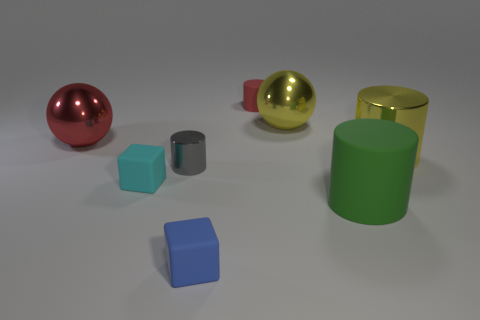There is a big object that is the same color as the small matte cylinder; what shape is it?
Provide a short and direct response. Sphere. The large shiny thing to the left of the small blue thing is what color?
Your answer should be compact. Red. Are there the same number of small gray metallic cylinders in front of the blue rubber thing and red rubber things to the right of the gray shiny cylinder?
Offer a very short reply. No. There is a big cylinder behind the metal cylinder that is to the left of the yellow metallic cylinder; what is its material?
Your response must be concise. Metal. How many things are rubber blocks or big spheres on the right side of the large red object?
Offer a very short reply. 3. What is the size of the green object that is the same material as the blue cube?
Offer a very short reply. Large. Are there more tiny blue rubber blocks that are in front of the large yellow shiny cylinder than purple matte spheres?
Offer a terse response. Yes. How big is the rubber thing that is both behind the green thing and in front of the tiny red rubber object?
Offer a very short reply. Small. What material is the gray thing that is the same shape as the small red object?
Your response must be concise. Metal. There is a matte cylinder behind the red metal object; is its size the same as the big matte cylinder?
Provide a succinct answer. No. 